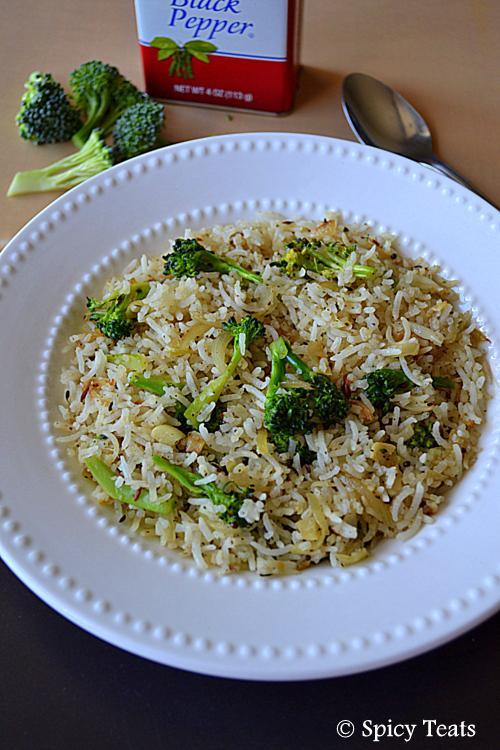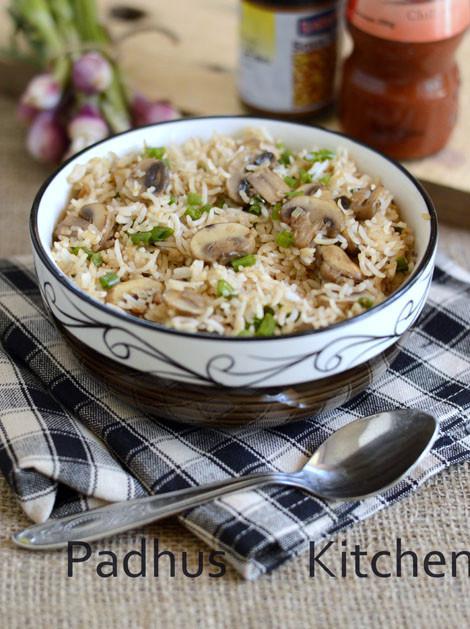The first image is the image on the left, the second image is the image on the right. Analyze the images presented: Is the assertion "There is at least one metal utensil in the image on the right." valid? Answer yes or no. Yes. 